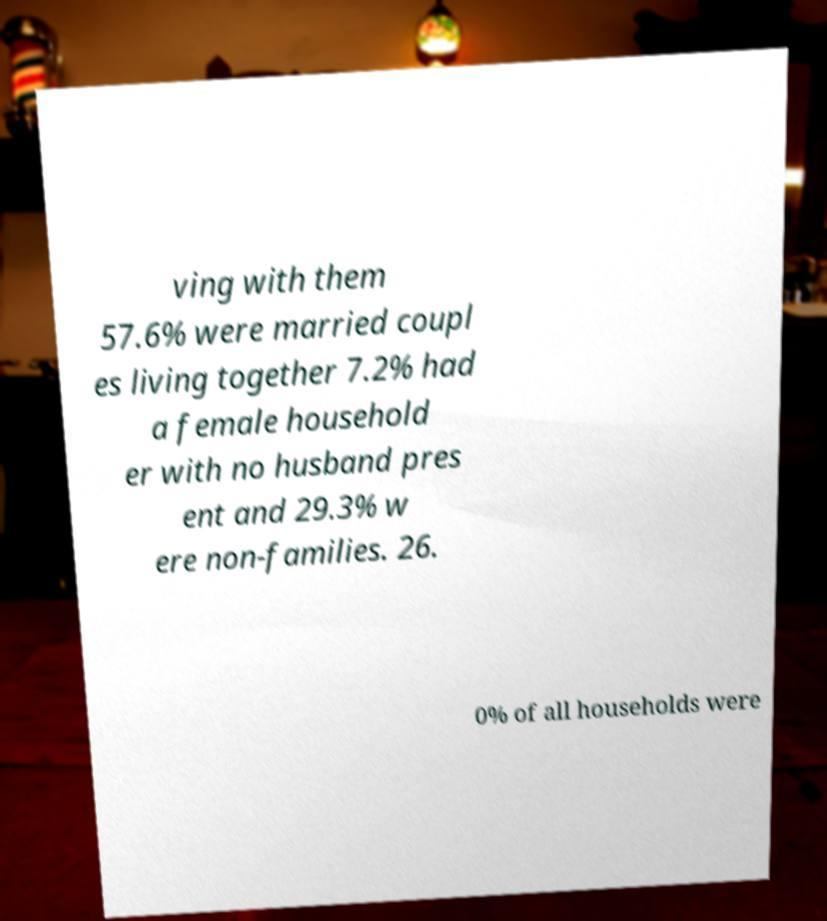I need the written content from this picture converted into text. Can you do that? ving with them 57.6% were married coupl es living together 7.2% had a female household er with no husband pres ent and 29.3% w ere non-families. 26. 0% of all households were 